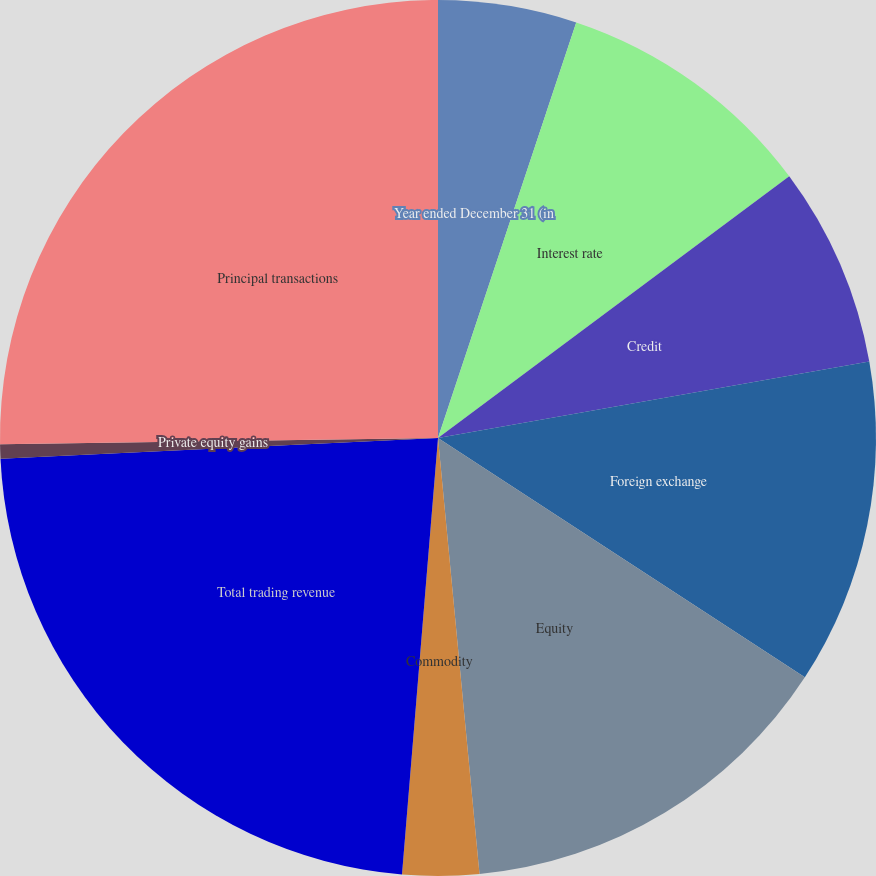Convert chart. <chart><loc_0><loc_0><loc_500><loc_500><pie_chart><fcel>Year ended December 31 (in<fcel>Interest rate<fcel>Credit<fcel>Foreign exchange<fcel>Equity<fcel>Commodity<fcel>Total trading revenue<fcel>Private equity gains<fcel>Principal transactions<nl><fcel>5.11%<fcel>9.7%<fcel>7.4%<fcel>11.99%<fcel>14.29%<fcel>2.82%<fcel>22.94%<fcel>0.52%<fcel>25.23%<nl></chart> 